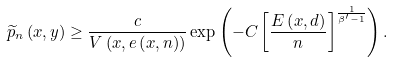Convert formula to latex. <formula><loc_0><loc_0><loc_500><loc_500>\widetilde { p } _ { n } \left ( x , y \right ) \geq \frac { c } { V \left ( x , e \left ( x , n \right ) \right ) } \exp \left ( - C \left [ \frac { E \left ( x , d \right ) } { n } \right ] ^ { \frac { 1 } { \beta ^ { \prime } - 1 } } \right ) .</formula> 